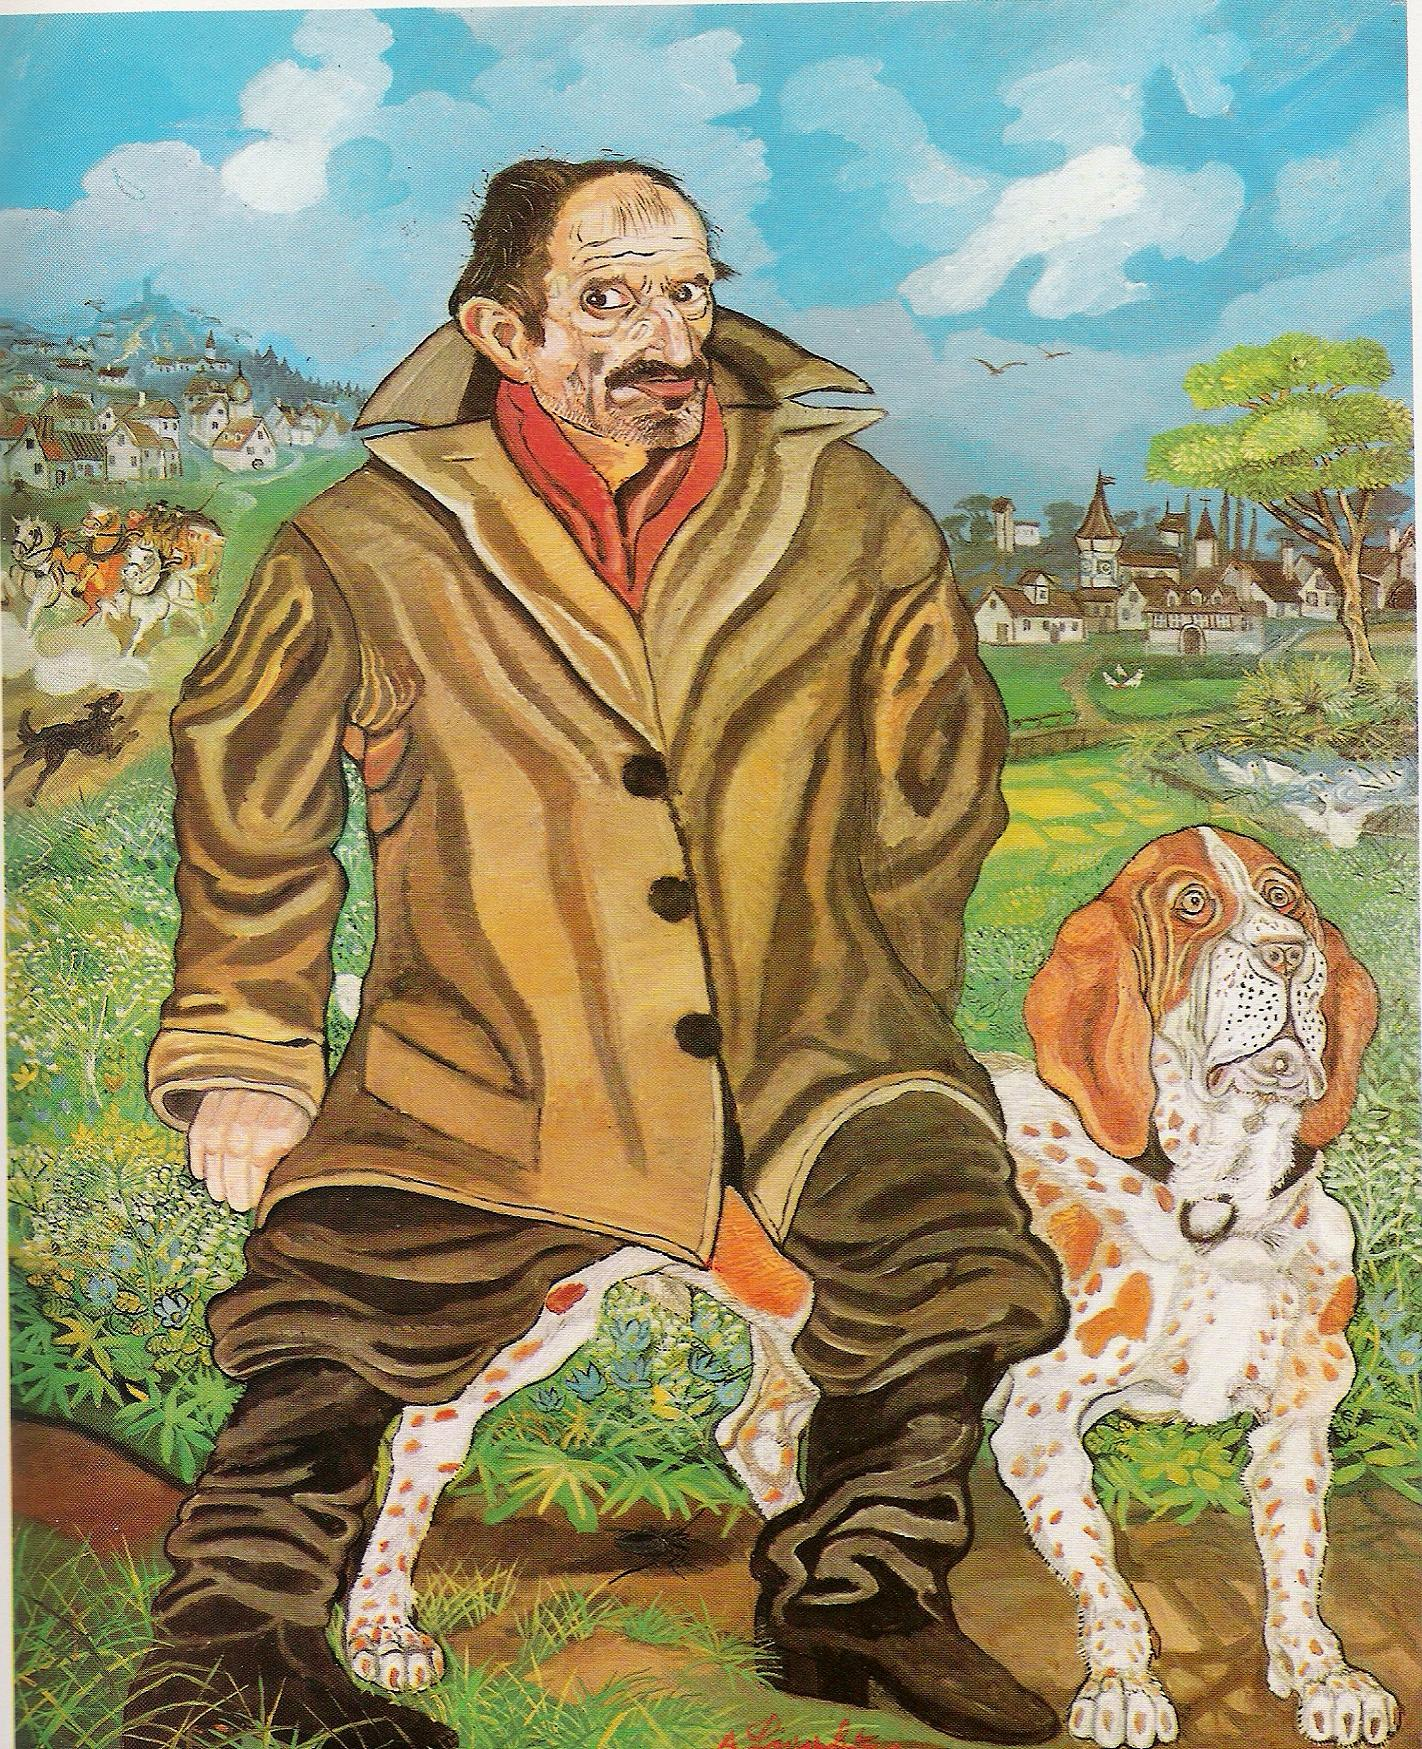Describe a realistic scenario where this man and his dog might be interacting with the background. The man and his dog could be out for a morning walk through the countryside. They might be on their way to the village market, where the man intends to buy some fresh produce and exchange news with the locals. The dog trots alongside, sniffing curiously at the ground and occasionally barking at birds flying overhead. As they approach the village, the man waves to familiar faces, and the dog wags its tail happily. The scene is serene and peaceful, with the village's clock tower chiming in the distance and the smell of fresh bread wafting through the air. Can you imagine a simple, short interaction they might have in the village? As the man and his dog enter the village square, they stop by a small bakery. The baker, a jovial old woman, greets them warmly. 'Good morning, Eldric! And hello to you, Bardo! How about a fresh loaf for today?' Eldric smiles and nods, 'Thank you, Clara. That would be perfect.' Bardo sits patiently, tail wagging, knowing that Clara always has a little treat for him. 